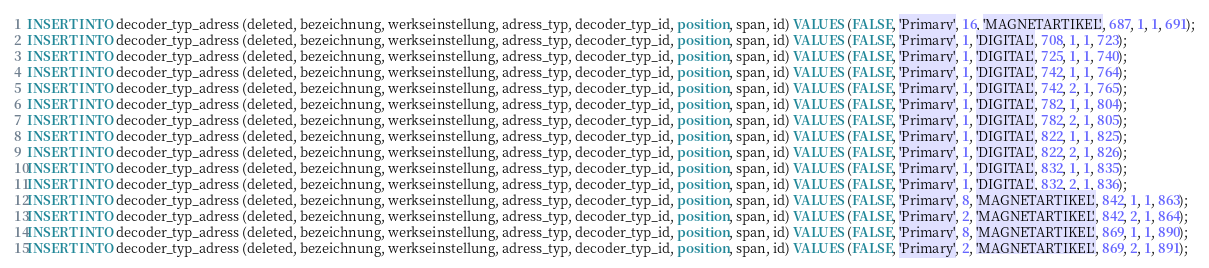<code> <loc_0><loc_0><loc_500><loc_500><_SQL_>INSERT INTO decoder_typ_adress (deleted, bezeichnung, werkseinstellung, adress_typ, decoder_typ_id, position, span, id) VALUES (FALSE, 'Primary', 16, 'MAGNETARTIKEL', 687, 1, 1, 691);
INSERT INTO decoder_typ_adress (deleted, bezeichnung, werkseinstellung, adress_typ, decoder_typ_id, position, span, id) VALUES (FALSE, 'Primary', 1, 'DIGITAL', 708, 1, 1, 723);
INSERT INTO decoder_typ_adress (deleted, bezeichnung, werkseinstellung, adress_typ, decoder_typ_id, position, span, id) VALUES (FALSE, 'Primary', 1, 'DIGITAL', 725, 1, 1, 740);
INSERT INTO decoder_typ_adress (deleted, bezeichnung, werkseinstellung, adress_typ, decoder_typ_id, position, span, id) VALUES (FALSE, 'Primary', 1, 'DIGITAL', 742, 1, 1, 764);
INSERT INTO decoder_typ_adress (deleted, bezeichnung, werkseinstellung, adress_typ, decoder_typ_id, position, span, id) VALUES (FALSE, 'Primary', 1, 'DIGITAL', 742, 2, 1, 765);
INSERT INTO decoder_typ_adress (deleted, bezeichnung, werkseinstellung, adress_typ, decoder_typ_id, position, span, id) VALUES (FALSE, 'Primary', 1, 'DIGITAL', 782, 1, 1, 804);
INSERT INTO decoder_typ_adress (deleted, bezeichnung, werkseinstellung, adress_typ, decoder_typ_id, position, span, id) VALUES (FALSE, 'Primary', 1, 'DIGITAL', 782, 2, 1, 805);
INSERT INTO decoder_typ_adress (deleted, bezeichnung, werkseinstellung, adress_typ, decoder_typ_id, position, span, id) VALUES (FALSE, 'Primary', 1, 'DIGITAL', 822, 1, 1, 825);
INSERT INTO decoder_typ_adress (deleted, bezeichnung, werkseinstellung, adress_typ, decoder_typ_id, position, span, id) VALUES (FALSE, 'Primary', 1, 'DIGITAL', 822, 2, 1, 826);
INSERT INTO decoder_typ_adress (deleted, bezeichnung, werkseinstellung, adress_typ, decoder_typ_id, position, span, id) VALUES (FALSE, 'Primary', 1, 'DIGITAL', 832, 1, 1, 835);
INSERT INTO decoder_typ_adress (deleted, bezeichnung, werkseinstellung, adress_typ, decoder_typ_id, position, span, id) VALUES (FALSE, 'Primary', 1, 'DIGITAL', 832, 2, 1, 836);
INSERT INTO decoder_typ_adress (deleted, bezeichnung, werkseinstellung, adress_typ, decoder_typ_id, position, span, id) VALUES (FALSE, 'Primary', 8, 'MAGNETARTIKEL', 842, 1, 1, 863);
INSERT INTO decoder_typ_adress (deleted, bezeichnung, werkseinstellung, adress_typ, decoder_typ_id, position, span, id) VALUES (FALSE, 'Primary', 2, 'MAGNETARTIKEL', 842, 2, 1, 864);
INSERT INTO decoder_typ_adress (deleted, bezeichnung, werkseinstellung, adress_typ, decoder_typ_id, position, span, id) VALUES (FALSE, 'Primary', 8, 'MAGNETARTIKEL', 869, 1, 1, 890);
INSERT INTO decoder_typ_adress (deleted, bezeichnung, werkseinstellung, adress_typ, decoder_typ_id, position, span, id) VALUES (FALSE, 'Primary', 2, 'MAGNETARTIKEL', 869, 2, 1, 891);</code> 